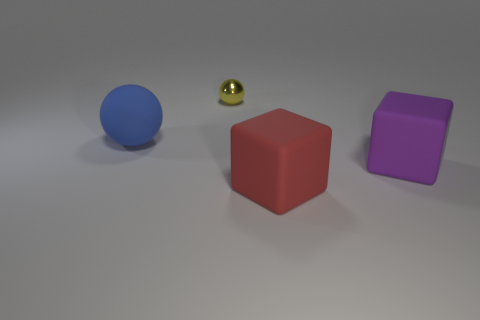Add 4 tiny red blocks. How many objects exist? 8 Subtract all blue balls. How many balls are left? 1 Subtract 1 spheres. How many spheres are left? 1 Add 1 purple blocks. How many purple blocks are left? 2 Add 2 large purple objects. How many large purple objects exist? 3 Subtract 1 yellow spheres. How many objects are left? 3 Subtract all cyan spheres. Subtract all yellow cubes. How many spheres are left? 2 Subtract all tiny cyan matte things. Subtract all tiny things. How many objects are left? 3 